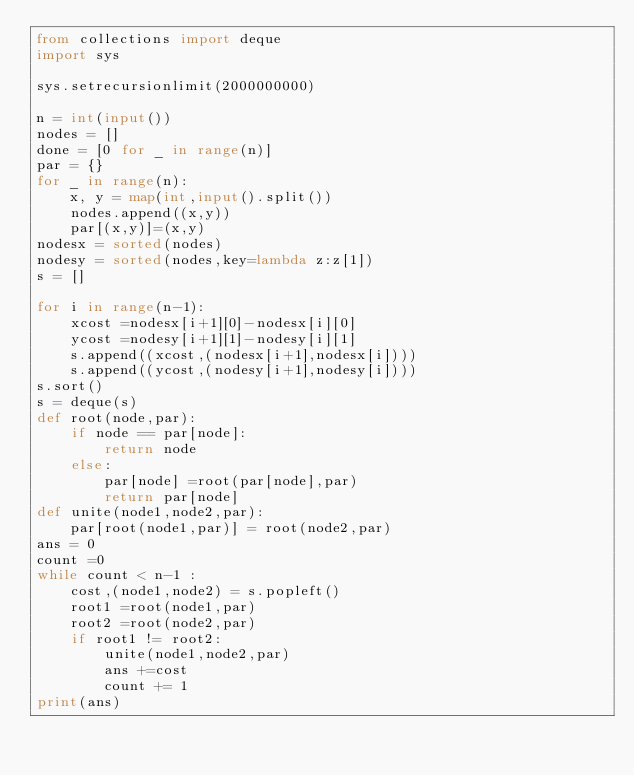Convert code to text. <code><loc_0><loc_0><loc_500><loc_500><_Python_>from collections import deque
import sys

sys.setrecursionlimit(2000000000)
 
n = int(input())
nodes = []
done = [0 for _ in range(n)]
par = {}
for _ in range(n):
    x, y = map(int,input().split())
    nodes.append((x,y))
    par[(x,y)]=(x,y)
nodesx = sorted(nodes)
nodesy = sorted(nodes,key=lambda z:z[1])
s = []
 
for i in range(n-1):
    xcost =nodesx[i+1][0]-nodesx[i][0]
    ycost =nodesy[i+1][1]-nodesy[i][1]
    s.append((xcost,(nodesx[i+1],nodesx[i])))
    s.append((ycost,(nodesy[i+1],nodesy[i])))
s.sort()
s = deque(s)
def root(node,par):
    if node == par[node]:
        return node
    else:
        par[node] =root(par[node],par)
        return par[node]
def unite(node1,node2,par):
    par[root(node1,par)] = root(node2,par)
ans = 0
count =0
while count < n-1 :
    cost,(node1,node2) = s.popleft()
    root1 =root(node1,par)
    root2 =root(node2,par)
    if root1 != root2:
        unite(node1,node2,par)
        ans +=cost
        count += 1
print(ans)
</code> 